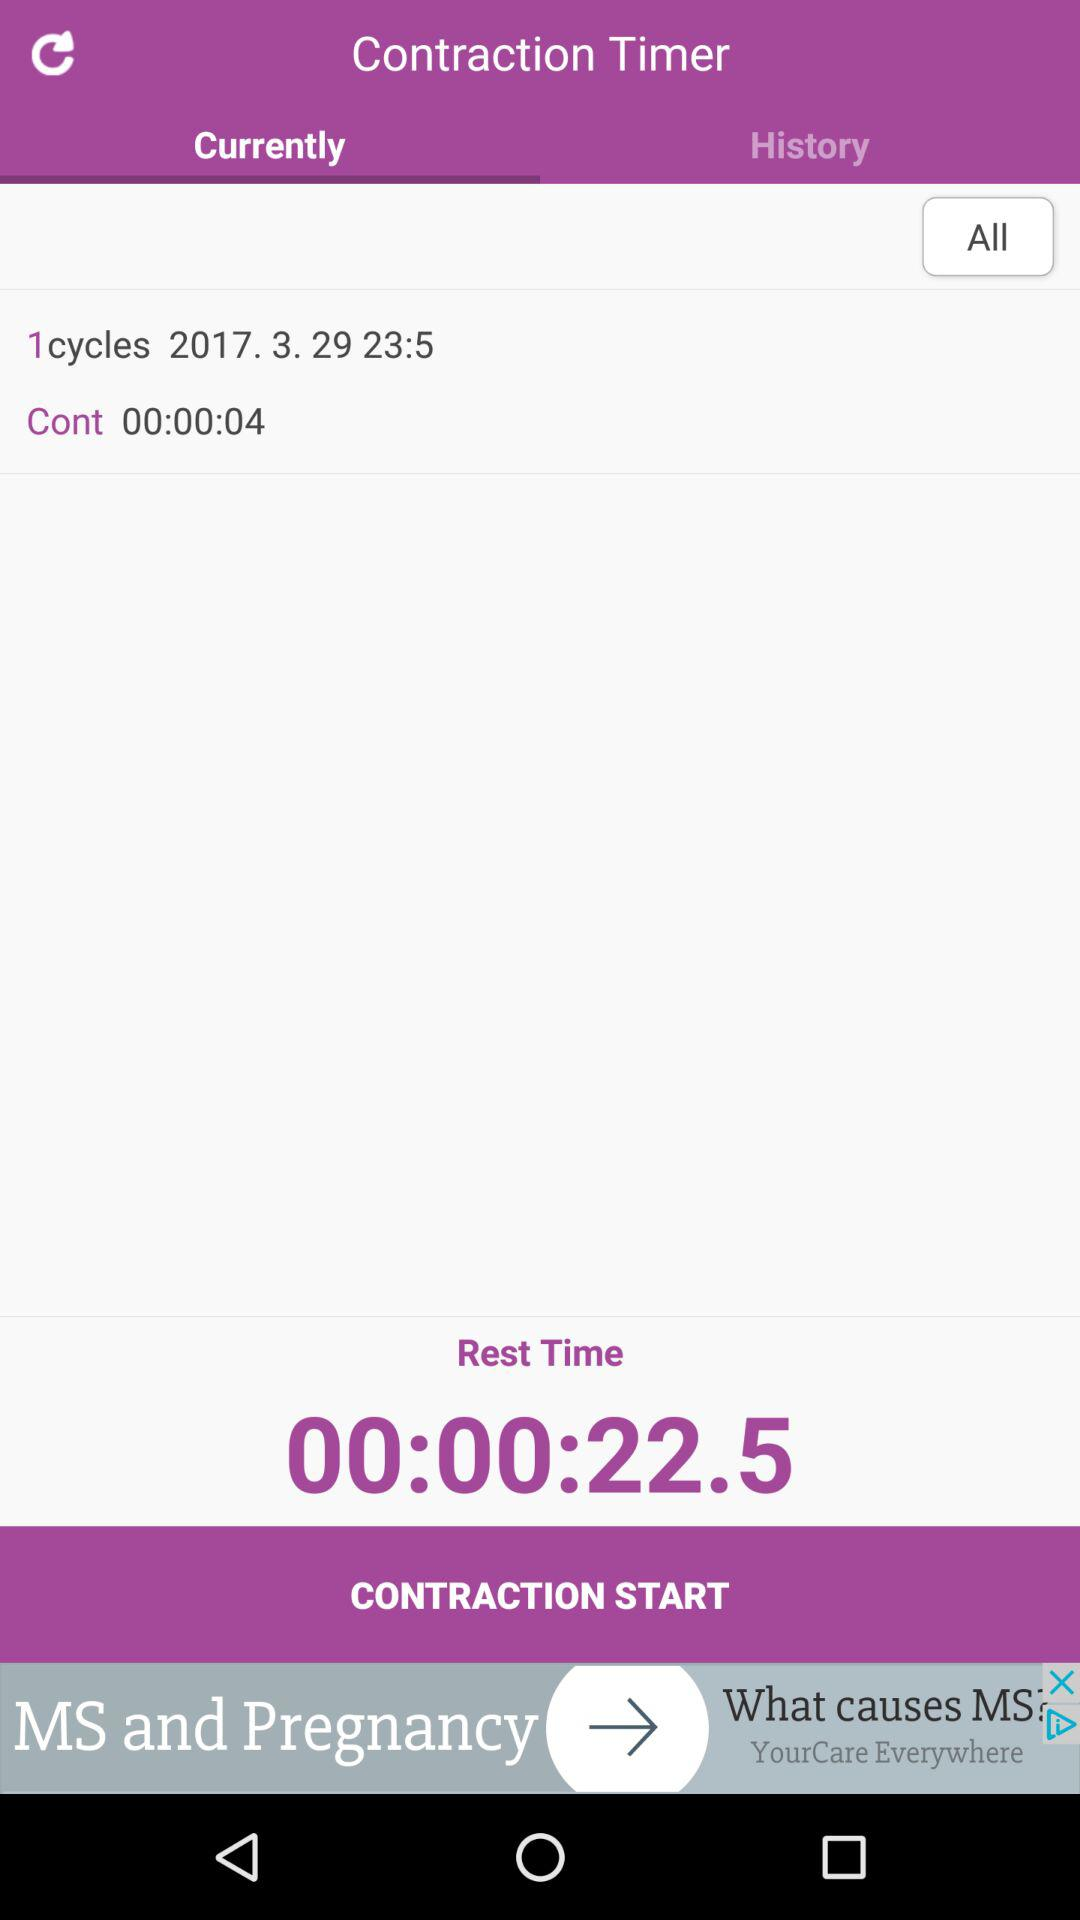Which tab am I using? The tab is "Currently". 